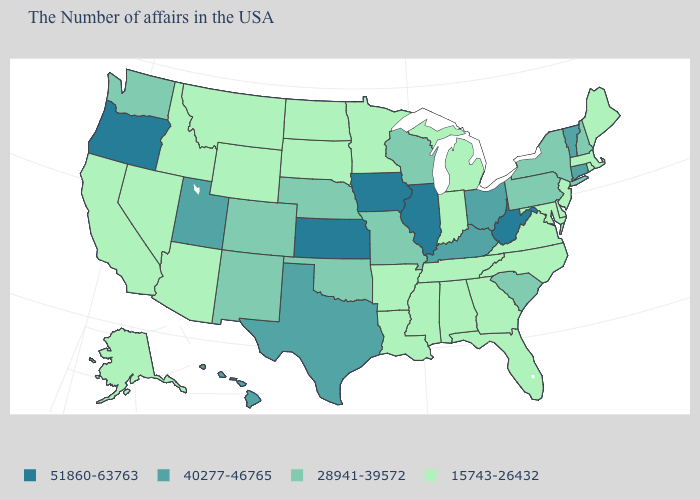What is the value of South Carolina?
Quick response, please. 28941-39572. Does the first symbol in the legend represent the smallest category?
Be succinct. No. Which states have the lowest value in the USA?
Short answer required. Maine, Massachusetts, Rhode Island, New Jersey, Delaware, Maryland, Virginia, North Carolina, Florida, Georgia, Michigan, Indiana, Alabama, Tennessee, Mississippi, Louisiana, Arkansas, Minnesota, South Dakota, North Dakota, Wyoming, Montana, Arizona, Idaho, Nevada, California, Alaska. What is the value of Connecticut?
Write a very short answer. 40277-46765. Name the states that have a value in the range 15743-26432?
Quick response, please. Maine, Massachusetts, Rhode Island, New Jersey, Delaware, Maryland, Virginia, North Carolina, Florida, Georgia, Michigan, Indiana, Alabama, Tennessee, Mississippi, Louisiana, Arkansas, Minnesota, South Dakota, North Dakota, Wyoming, Montana, Arizona, Idaho, Nevada, California, Alaska. Name the states that have a value in the range 51860-63763?
Concise answer only. West Virginia, Illinois, Iowa, Kansas, Oregon. Does Pennsylvania have a higher value than Iowa?
Write a very short answer. No. Does Maryland have the same value as Minnesota?
Give a very brief answer. Yes. What is the value of Wyoming?
Concise answer only. 15743-26432. What is the value of Rhode Island?
Be succinct. 15743-26432. Which states hav the highest value in the West?
Concise answer only. Oregon. What is the highest value in states that border Ohio?
Short answer required. 51860-63763. What is the highest value in states that border Ohio?
Answer briefly. 51860-63763. Which states have the lowest value in the MidWest?
Concise answer only. Michigan, Indiana, Minnesota, South Dakota, North Dakota. Name the states that have a value in the range 40277-46765?
Keep it brief. Vermont, Connecticut, Ohio, Kentucky, Texas, Utah, Hawaii. 